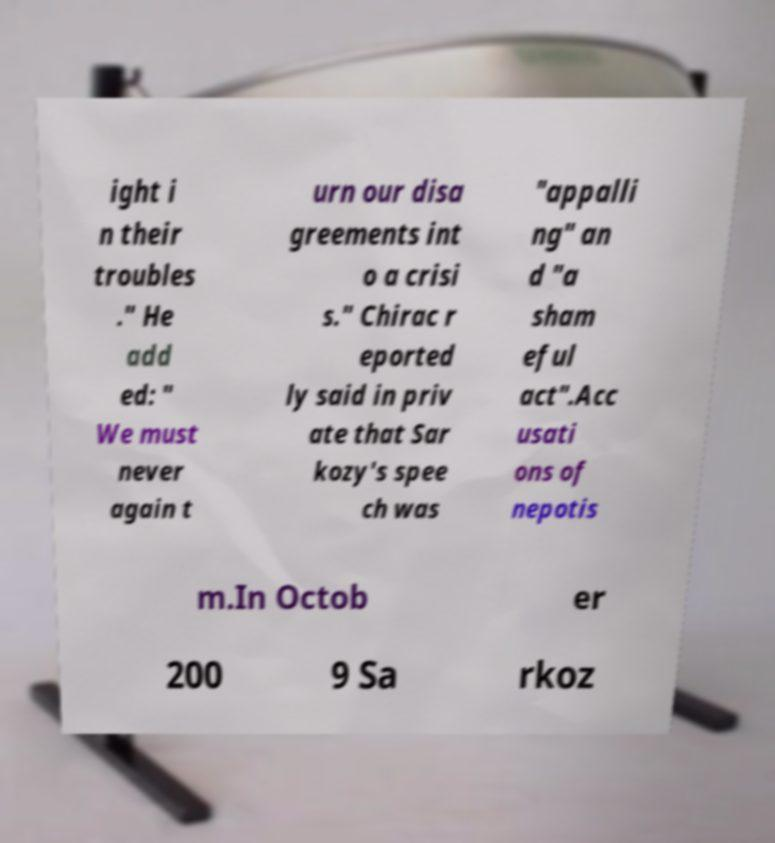Can you accurately transcribe the text from the provided image for me? ight i n their troubles ." He add ed: " We must never again t urn our disa greements int o a crisi s." Chirac r eported ly said in priv ate that Sar kozy's spee ch was "appalli ng" an d "a sham eful act".Acc usati ons of nepotis m.In Octob er 200 9 Sa rkoz 